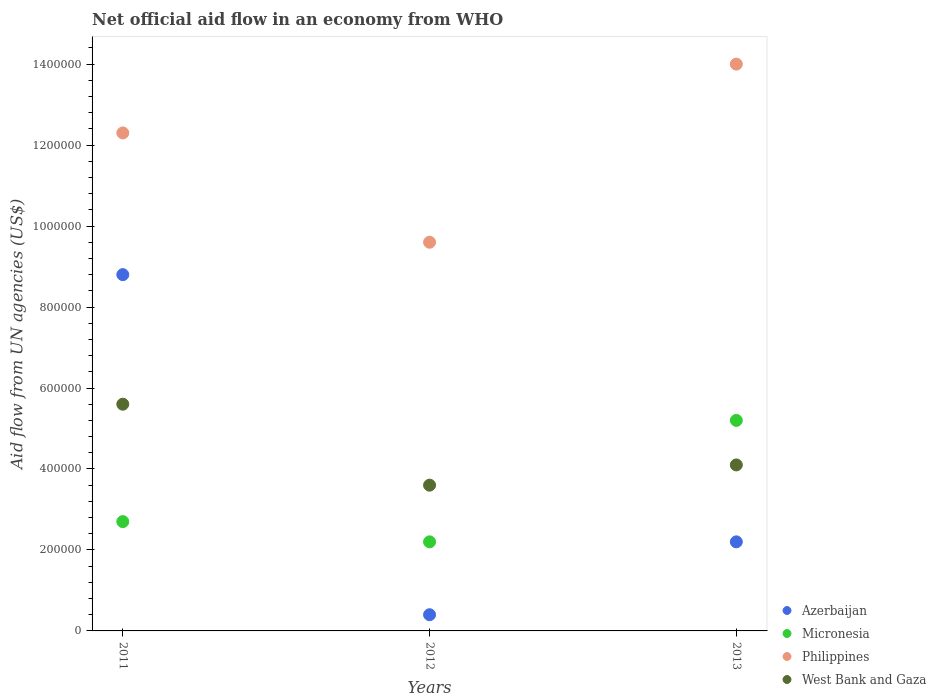How many different coloured dotlines are there?
Your answer should be very brief. 4. Is the number of dotlines equal to the number of legend labels?
Keep it short and to the point. Yes. What is the net official aid flow in Azerbaijan in 2011?
Your answer should be compact. 8.80e+05. Across all years, what is the maximum net official aid flow in Azerbaijan?
Make the answer very short. 8.80e+05. In which year was the net official aid flow in Micronesia minimum?
Your answer should be compact. 2012. What is the total net official aid flow in Micronesia in the graph?
Provide a succinct answer. 1.01e+06. What is the difference between the net official aid flow in West Bank and Gaza in 2012 and that in 2013?
Make the answer very short. -5.00e+04. What is the difference between the net official aid flow in Azerbaijan in 2011 and the net official aid flow in Philippines in 2012?
Offer a terse response. -8.00e+04. What is the average net official aid flow in Philippines per year?
Your answer should be very brief. 1.20e+06. In the year 2013, what is the difference between the net official aid flow in Azerbaijan and net official aid flow in West Bank and Gaza?
Offer a very short reply. -1.90e+05. In how many years, is the net official aid flow in Azerbaijan greater than 1040000 US$?
Offer a very short reply. 0. What is the ratio of the net official aid flow in West Bank and Gaza in 2011 to that in 2013?
Your response must be concise. 1.37. Is the net official aid flow in Philippines in 2011 less than that in 2012?
Provide a short and direct response. No. Is the difference between the net official aid flow in Azerbaijan in 2012 and 2013 greater than the difference between the net official aid flow in West Bank and Gaza in 2012 and 2013?
Your response must be concise. No. What is the difference between the highest and the second highest net official aid flow in West Bank and Gaza?
Provide a short and direct response. 1.50e+05. What is the difference between the highest and the lowest net official aid flow in Azerbaijan?
Your answer should be compact. 8.40e+05. In how many years, is the net official aid flow in Micronesia greater than the average net official aid flow in Micronesia taken over all years?
Provide a succinct answer. 1. Is the sum of the net official aid flow in West Bank and Gaza in 2011 and 2012 greater than the maximum net official aid flow in Micronesia across all years?
Keep it short and to the point. Yes. Is the net official aid flow in Azerbaijan strictly less than the net official aid flow in West Bank and Gaza over the years?
Ensure brevity in your answer.  No. How many dotlines are there?
Ensure brevity in your answer.  4. What is the difference between two consecutive major ticks on the Y-axis?
Make the answer very short. 2.00e+05. Are the values on the major ticks of Y-axis written in scientific E-notation?
Make the answer very short. No. Does the graph contain any zero values?
Provide a short and direct response. No. Does the graph contain grids?
Give a very brief answer. No. Where does the legend appear in the graph?
Offer a terse response. Bottom right. How are the legend labels stacked?
Your response must be concise. Vertical. What is the title of the graph?
Offer a very short reply. Net official aid flow in an economy from WHO. Does "Sub-Saharan Africa (all income levels)" appear as one of the legend labels in the graph?
Provide a short and direct response. No. What is the label or title of the Y-axis?
Offer a very short reply. Aid flow from UN agencies (US$). What is the Aid flow from UN agencies (US$) in Azerbaijan in 2011?
Provide a short and direct response. 8.80e+05. What is the Aid flow from UN agencies (US$) of Philippines in 2011?
Provide a succinct answer. 1.23e+06. What is the Aid flow from UN agencies (US$) in West Bank and Gaza in 2011?
Ensure brevity in your answer.  5.60e+05. What is the Aid flow from UN agencies (US$) in Micronesia in 2012?
Provide a succinct answer. 2.20e+05. What is the Aid flow from UN agencies (US$) in Philippines in 2012?
Offer a very short reply. 9.60e+05. What is the Aid flow from UN agencies (US$) of West Bank and Gaza in 2012?
Offer a terse response. 3.60e+05. What is the Aid flow from UN agencies (US$) in Micronesia in 2013?
Offer a very short reply. 5.20e+05. What is the Aid flow from UN agencies (US$) of Philippines in 2013?
Make the answer very short. 1.40e+06. What is the Aid flow from UN agencies (US$) of West Bank and Gaza in 2013?
Provide a succinct answer. 4.10e+05. Across all years, what is the maximum Aid flow from UN agencies (US$) in Azerbaijan?
Your answer should be very brief. 8.80e+05. Across all years, what is the maximum Aid flow from UN agencies (US$) of Micronesia?
Make the answer very short. 5.20e+05. Across all years, what is the maximum Aid flow from UN agencies (US$) of Philippines?
Ensure brevity in your answer.  1.40e+06. Across all years, what is the maximum Aid flow from UN agencies (US$) in West Bank and Gaza?
Ensure brevity in your answer.  5.60e+05. Across all years, what is the minimum Aid flow from UN agencies (US$) in Philippines?
Offer a terse response. 9.60e+05. Across all years, what is the minimum Aid flow from UN agencies (US$) in West Bank and Gaza?
Provide a short and direct response. 3.60e+05. What is the total Aid flow from UN agencies (US$) of Azerbaijan in the graph?
Your response must be concise. 1.14e+06. What is the total Aid flow from UN agencies (US$) of Micronesia in the graph?
Keep it short and to the point. 1.01e+06. What is the total Aid flow from UN agencies (US$) in Philippines in the graph?
Provide a short and direct response. 3.59e+06. What is the total Aid flow from UN agencies (US$) of West Bank and Gaza in the graph?
Your response must be concise. 1.33e+06. What is the difference between the Aid flow from UN agencies (US$) in Azerbaijan in 2011 and that in 2012?
Your answer should be very brief. 8.40e+05. What is the difference between the Aid flow from UN agencies (US$) of Micronesia in 2011 and that in 2012?
Offer a very short reply. 5.00e+04. What is the difference between the Aid flow from UN agencies (US$) of Philippines in 2011 and that in 2012?
Ensure brevity in your answer.  2.70e+05. What is the difference between the Aid flow from UN agencies (US$) of West Bank and Gaza in 2011 and that in 2012?
Make the answer very short. 2.00e+05. What is the difference between the Aid flow from UN agencies (US$) of Azerbaijan in 2011 and that in 2013?
Make the answer very short. 6.60e+05. What is the difference between the Aid flow from UN agencies (US$) of Philippines in 2012 and that in 2013?
Give a very brief answer. -4.40e+05. What is the difference between the Aid flow from UN agencies (US$) of West Bank and Gaza in 2012 and that in 2013?
Give a very brief answer. -5.00e+04. What is the difference between the Aid flow from UN agencies (US$) of Azerbaijan in 2011 and the Aid flow from UN agencies (US$) of Micronesia in 2012?
Offer a very short reply. 6.60e+05. What is the difference between the Aid flow from UN agencies (US$) in Azerbaijan in 2011 and the Aid flow from UN agencies (US$) in Philippines in 2012?
Your answer should be very brief. -8.00e+04. What is the difference between the Aid flow from UN agencies (US$) of Azerbaijan in 2011 and the Aid flow from UN agencies (US$) of West Bank and Gaza in 2012?
Your answer should be compact. 5.20e+05. What is the difference between the Aid flow from UN agencies (US$) in Micronesia in 2011 and the Aid flow from UN agencies (US$) in Philippines in 2012?
Provide a short and direct response. -6.90e+05. What is the difference between the Aid flow from UN agencies (US$) in Philippines in 2011 and the Aid flow from UN agencies (US$) in West Bank and Gaza in 2012?
Ensure brevity in your answer.  8.70e+05. What is the difference between the Aid flow from UN agencies (US$) of Azerbaijan in 2011 and the Aid flow from UN agencies (US$) of Philippines in 2013?
Offer a terse response. -5.20e+05. What is the difference between the Aid flow from UN agencies (US$) of Micronesia in 2011 and the Aid flow from UN agencies (US$) of Philippines in 2013?
Make the answer very short. -1.13e+06. What is the difference between the Aid flow from UN agencies (US$) in Micronesia in 2011 and the Aid flow from UN agencies (US$) in West Bank and Gaza in 2013?
Provide a short and direct response. -1.40e+05. What is the difference between the Aid flow from UN agencies (US$) of Philippines in 2011 and the Aid flow from UN agencies (US$) of West Bank and Gaza in 2013?
Give a very brief answer. 8.20e+05. What is the difference between the Aid flow from UN agencies (US$) in Azerbaijan in 2012 and the Aid flow from UN agencies (US$) in Micronesia in 2013?
Your answer should be compact. -4.80e+05. What is the difference between the Aid flow from UN agencies (US$) in Azerbaijan in 2012 and the Aid flow from UN agencies (US$) in Philippines in 2013?
Provide a short and direct response. -1.36e+06. What is the difference between the Aid flow from UN agencies (US$) in Azerbaijan in 2012 and the Aid flow from UN agencies (US$) in West Bank and Gaza in 2013?
Your response must be concise. -3.70e+05. What is the difference between the Aid flow from UN agencies (US$) of Micronesia in 2012 and the Aid flow from UN agencies (US$) of Philippines in 2013?
Ensure brevity in your answer.  -1.18e+06. What is the difference between the Aid flow from UN agencies (US$) of Philippines in 2012 and the Aid flow from UN agencies (US$) of West Bank and Gaza in 2013?
Offer a very short reply. 5.50e+05. What is the average Aid flow from UN agencies (US$) of Micronesia per year?
Make the answer very short. 3.37e+05. What is the average Aid flow from UN agencies (US$) of Philippines per year?
Provide a succinct answer. 1.20e+06. What is the average Aid flow from UN agencies (US$) in West Bank and Gaza per year?
Keep it short and to the point. 4.43e+05. In the year 2011, what is the difference between the Aid flow from UN agencies (US$) in Azerbaijan and Aid flow from UN agencies (US$) in Philippines?
Ensure brevity in your answer.  -3.50e+05. In the year 2011, what is the difference between the Aid flow from UN agencies (US$) of Azerbaijan and Aid flow from UN agencies (US$) of West Bank and Gaza?
Provide a short and direct response. 3.20e+05. In the year 2011, what is the difference between the Aid flow from UN agencies (US$) of Micronesia and Aid flow from UN agencies (US$) of Philippines?
Provide a succinct answer. -9.60e+05. In the year 2011, what is the difference between the Aid flow from UN agencies (US$) in Micronesia and Aid flow from UN agencies (US$) in West Bank and Gaza?
Offer a very short reply. -2.90e+05. In the year 2011, what is the difference between the Aid flow from UN agencies (US$) in Philippines and Aid flow from UN agencies (US$) in West Bank and Gaza?
Offer a terse response. 6.70e+05. In the year 2012, what is the difference between the Aid flow from UN agencies (US$) of Azerbaijan and Aid flow from UN agencies (US$) of Philippines?
Provide a succinct answer. -9.20e+05. In the year 2012, what is the difference between the Aid flow from UN agencies (US$) in Azerbaijan and Aid flow from UN agencies (US$) in West Bank and Gaza?
Your response must be concise. -3.20e+05. In the year 2012, what is the difference between the Aid flow from UN agencies (US$) in Micronesia and Aid flow from UN agencies (US$) in Philippines?
Provide a short and direct response. -7.40e+05. In the year 2012, what is the difference between the Aid flow from UN agencies (US$) in Philippines and Aid flow from UN agencies (US$) in West Bank and Gaza?
Keep it short and to the point. 6.00e+05. In the year 2013, what is the difference between the Aid flow from UN agencies (US$) of Azerbaijan and Aid flow from UN agencies (US$) of Micronesia?
Provide a short and direct response. -3.00e+05. In the year 2013, what is the difference between the Aid flow from UN agencies (US$) in Azerbaijan and Aid flow from UN agencies (US$) in Philippines?
Provide a short and direct response. -1.18e+06. In the year 2013, what is the difference between the Aid flow from UN agencies (US$) of Azerbaijan and Aid flow from UN agencies (US$) of West Bank and Gaza?
Offer a very short reply. -1.90e+05. In the year 2013, what is the difference between the Aid flow from UN agencies (US$) of Micronesia and Aid flow from UN agencies (US$) of Philippines?
Provide a short and direct response. -8.80e+05. In the year 2013, what is the difference between the Aid flow from UN agencies (US$) in Micronesia and Aid flow from UN agencies (US$) in West Bank and Gaza?
Offer a terse response. 1.10e+05. In the year 2013, what is the difference between the Aid flow from UN agencies (US$) in Philippines and Aid flow from UN agencies (US$) in West Bank and Gaza?
Give a very brief answer. 9.90e+05. What is the ratio of the Aid flow from UN agencies (US$) of Azerbaijan in 2011 to that in 2012?
Keep it short and to the point. 22. What is the ratio of the Aid flow from UN agencies (US$) in Micronesia in 2011 to that in 2012?
Ensure brevity in your answer.  1.23. What is the ratio of the Aid flow from UN agencies (US$) in Philippines in 2011 to that in 2012?
Keep it short and to the point. 1.28. What is the ratio of the Aid flow from UN agencies (US$) in West Bank and Gaza in 2011 to that in 2012?
Make the answer very short. 1.56. What is the ratio of the Aid flow from UN agencies (US$) in Micronesia in 2011 to that in 2013?
Provide a short and direct response. 0.52. What is the ratio of the Aid flow from UN agencies (US$) in Philippines in 2011 to that in 2013?
Your answer should be compact. 0.88. What is the ratio of the Aid flow from UN agencies (US$) in West Bank and Gaza in 2011 to that in 2013?
Offer a very short reply. 1.37. What is the ratio of the Aid flow from UN agencies (US$) in Azerbaijan in 2012 to that in 2013?
Your response must be concise. 0.18. What is the ratio of the Aid flow from UN agencies (US$) in Micronesia in 2012 to that in 2013?
Make the answer very short. 0.42. What is the ratio of the Aid flow from UN agencies (US$) of Philippines in 2012 to that in 2013?
Your response must be concise. 0.69. What is the ratio of the Aid flow from UN agencies (US$) in West Bank and Gaza in 2012 to that in 2013?
Ensure brevity in your answer.  0.88. What is the difference between the highest and the second highest Aid flow from UN agencies (US$) of Azerbaijan?
Provide a succinct answer. 6.60e+05. What is the difference between the highest and the second highest Aid flow from UN agencies (US$) of Micronesia?
Your response must be concise. 2.50e+05. What is the difference between the highest and the second highest Aid flow from UN agencies (US$) in Philippines?
Offer a very short reply. 1.70e+05. What is the difference between the highest and the lowest Aid flow from UN agencies (US$) of Azerbaijan?
Your answer should be very brief. 8.40e+05. 